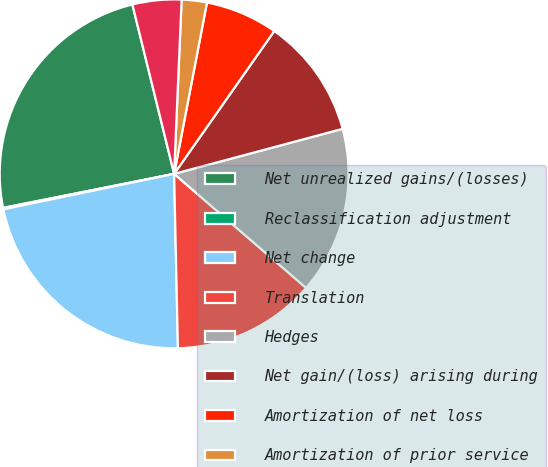<chart> <loc_0><loc_0><loc_500><loc_500><pie_chart><fcel>Net unrealized gains/(losses)<fcel>Reclassification adjustment<fcel>Net change<fcel>Translation<fcel>Hedges<fcel>Net gain/(loss) arising during<fcel>Amortization of net loss<fcel>Amortization of prior service<fcel>Foreign exchange and other<nl><fcel>24.28%<fcel>0.14%<fcel>22.08%<fcel>13.31%<fcel>15.5%<fcel>11.11%<fcel>6.72%<fcel>2.33%<fcel>4.53%<nl></chart> 